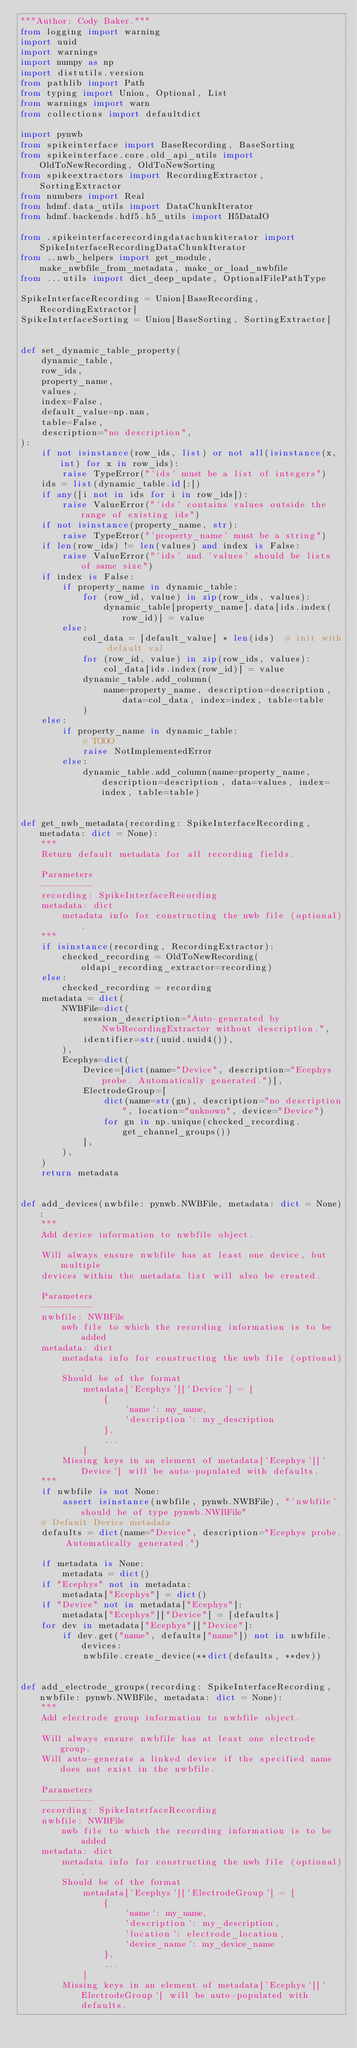<code> <loc_0><loc_0><loc_500><loc_500><_Python_>"""Author: Cody Baker."""
from logging import warning
import uuid
import warnings
import numpy as np
import distutils.version
from pathlib import Path
from typing import Union, Optional, List
from warnings import warn
from collections import defaultdict

import pynwb
from spikeinterface import BaseRecording, BaseSorting
from spikeinterface.core.old_api_utils import OldToNewRecording, OldToNewSorting
from spikeextractors import RecordingExtractor, SortingExtractor
from numbers import Real
from hdmf.data_utils import DataChunkIterator
from hdmf.backends.hdf5.h5_utils import H5DataIO

from .spikeinterfacerecordingdatachunkiterator import SpikeInterfaceRecordingDataChunkIterator
from ..nwb_helpers import get_module, make_nwbfile_from_metadata, make_or_load_nwbfile
from ...utils import dict_deep_update, OptionalFilePathType

SpikeInterfaceRecording = Union[BaseRecording, RecordingExtractor]
SpikeInterfaceSorting = Union[BaseSorting, SortingExtractor]


def set_dynamic_table_property(
    dynamic_table,
    row_ids,
    property_name,
    values,
    index=False,
    default_value=np.nan,
    table=False,
    description="no description",
):
    if not isinstance(row_ids, list) or not all(isinstance(x, int) for x in row_ids):
        raise TypeError("'ids' must be a list of integers")
    ids = list(dynamic_table.id[:])
    if any([i not in ids for i in row_ids]):
        raise ValueError("'ids' contains values outside the range of existing ids")
    if not isinstance(property_name, str):
        raise TypeError("'property_name' must be a string")
    if len(row_ids) != len(values) and index is False:
        raise ValueError("'ids' and 'values' should be lists of same size")
    if index is False:
        if property_name in dynamic_table:
            for (row_id, value) in zip(row_ids, values):
                dynamic_table[property_name].data[ids.index(row_id)] = value
        else:
            col_data = [default_value] * len(ids)  # init with default val
            for (row_id, value) in zip(row_ids, values):
                col_data[ids.index(row_id)] = value
            dynamic_table.add_column(
                name=property_name, description=description, data=col_data, index=index, table=table
            )
    else:
        if property_name in dynamic_table:
            # TODO
            raise NotImplementedError
        else:
            dynamic_table.add_column(name=property_name, description=description, data=values, index=index, table=table)


def get_nwb_metadata(recording: SpikeInterfaceRecording, metadata: dict = None):
    """
    Return default metadata for all recording fields.

    Parameters
    ----------
    recording: SpikeInterfaceRecording
    metadata: dict
        metadata info for constructing the nwb file (optional).
    """
    if isinstance(recording, RecordingExtractor):
        checked_recording = OldToNewRecording(oldapi_recording_extractor=recording)
    else:
        checked_recording = recording
    metadata = dict(
        NWBFile=dict(
            session_description="Auto-generated by NwbRecordingExtractor without description.",
            identifier=str(uuid.uuid4()),
        ),
        Ecephys=dict(
            Device=[dict(name="Device", description="Ecephys probe. Automatically generated.")],
            ElectrodeGroup=[
                dict(name=str(gn), description="no description", location="unknown", device="Device")
                for gn in np.unique(checked_recording.get_channel_groups())
            ],
        ),
    )
    return metadata


def add_devices(nwbfile: pynwb.NWBFile, metadata: dict = None):
    """
    Add device information to nwbfile object.

    Will always ensure nwbfile has at least one device, but multiple
    devices within the metadata list will also be created.

    Parameters
    ----------
    nwbfile: NWBFile
        nwb file to which the recording information is to be added
    metadata: dict
        metadata info for constructing the nwb file (optional).
        Should be of the format
            metadata['Ecephys']['Device'] = [
                {
                    'name': my_name,
                    'description': my_description
                },
                ...
            ]
        Missing keys in an element of metadata['Ecephys']['Device'] will be auto-populated with defaults.
    """
    if nwbfile is not None:
        assert isinstance(nwbfile, pynwb.NWBFile), "'nwbfile' should be of type pynwb.NWBFile"
    # Default Device metadata
    defaults = dict(name="Device", description="Ecephys probe. Automatically generated.")

    if metadata is None:
        metadata = dict()
    if "Ecephys" not in metadata:
        metadata["Ecephys"] = dict()
    if "Device" not in metadata["Ecephys"]:
        metadata["Ecephys"]["Device"] = [defaults]
    for dev in metadata["Ecephys"]["Device"]:
        if dev.get("name", defaults["name"]) not in nwbfile.devices:
            nwbfile.create_device(**dict(defaults, **dev))


def add_electrode_groups(recording: SpikeInterfaceRecording, nwbfile: pynwb.NWBFile, metadata: dict = None):
    """
    Add electrode group information to nwbfile object.

    Will always ensure nwbfile has at least one electrode group.
    Will auto-generate a linked device if the specified name does not exist in the nwbfile.

    Parameters
    ----------
    recording: SpikeInterfaceRecording
    nwbfile: NWBFile
        nwb file to which the recording information is to be added
    metadata: dict
        metadata info for constructing the nwb file (optional).
        Should be of the format
            metadata['Ecephys']['ElectrodeGroup'] = [
                {
                    'name': my_name,
                    'description': my_description,
                    'location': electrode_location,
                    'device_name': my_device_name
                },
                ...
            ]
        Missing keys in an element of metadata['Ecephys']['ElectrodeGroup'] will be auto-populated with defaults.</code> 